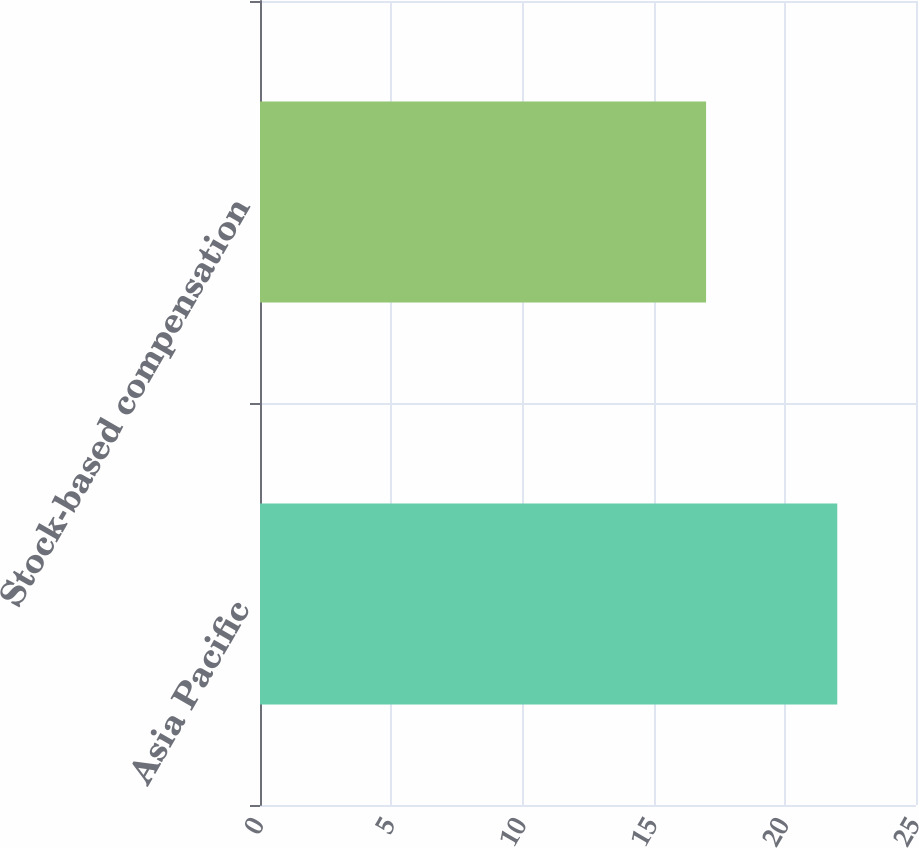<chart> <loc_0><loc_0><loc_500><loc_500><bar_chart><fcel>Asia Pacific<fcel>Stock-based compensation<nl><fcel>22<fcel>17<nl></chart> 